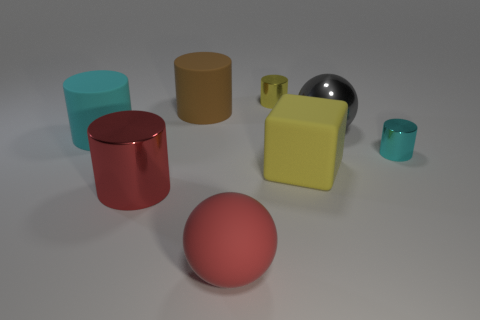What number of other large objects have the same shape as the red metallic thing?
Your answer should be compact. 2. There is a gray object; what shape is it?
Offer a very short reply. Sphere. Is the number of large red metallic objects less than the number of purple spheres?
Offer a very short reply. No. There is a gray object that is the same shape as the red rubber object; what is it made of?
Your response must be concise. Metal. Is the number of cyan cylinders greater than the number of tiny cyan shiny objects?
Provide a succinct answer. Yes. What number of other objects are the same color as the shiny sphere?
Give a very brief answer. 0. Is the material of the large red ball the same as the large sphere behind the large red cylinder?
Make the answer very short. No. There is a cyan thing that is to the left of the shiny cylinder to the left of the large red sphere; what number of gray objects are behind it?
Your answer should be compact. 1. Is the number of red metal objects that are behind the rubber block less than the number of gray objects that are on the right side of the yellow cylinder?
Provide a short and direct response. Yes. What number of other objects are there of the same material as the big yellow object?
Keep it short and to the point. 3. 